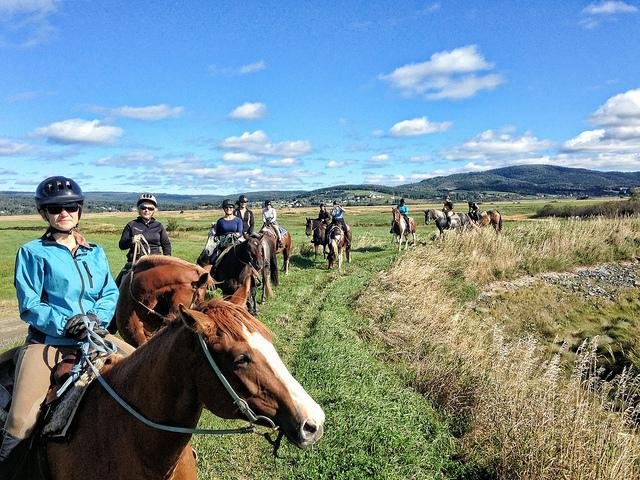What do these horseback riders ride along? Please explain your reasoning. streambed. It is a natural ditch full of grass and stones, with tall reeds along the edge. 